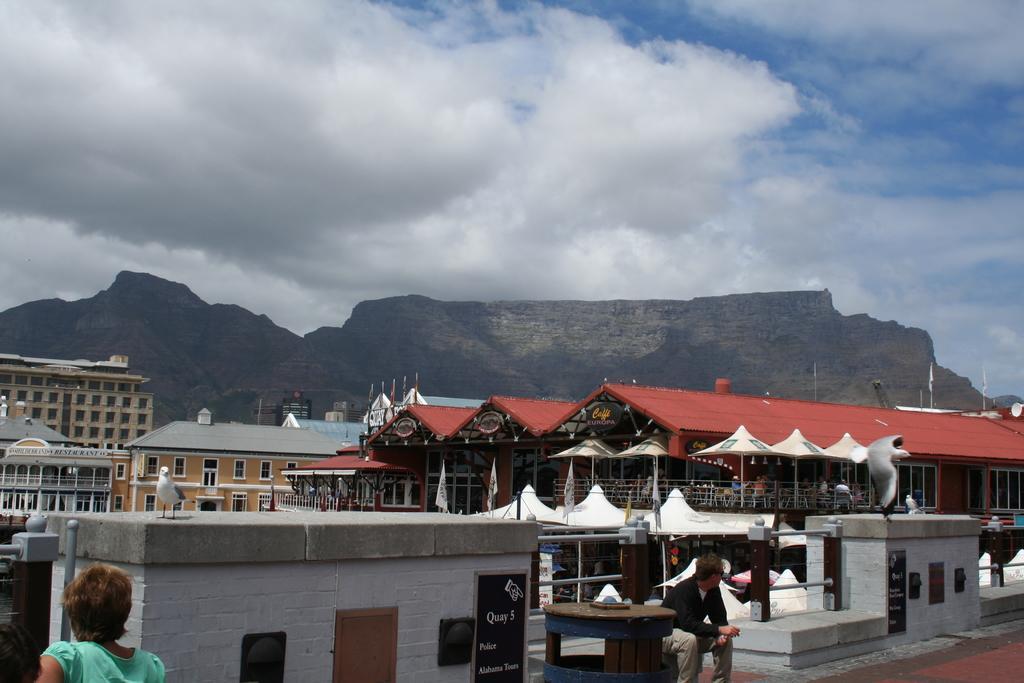In one or two sentences, can you explain what this image depicts? In the foreground of this picture, there is a woman behind her there is a wall and railing. There is also a man sitting in front of the wall. In the background, there are buildings, tents, umbrellas, flags, mountains, sky and the cloud. 